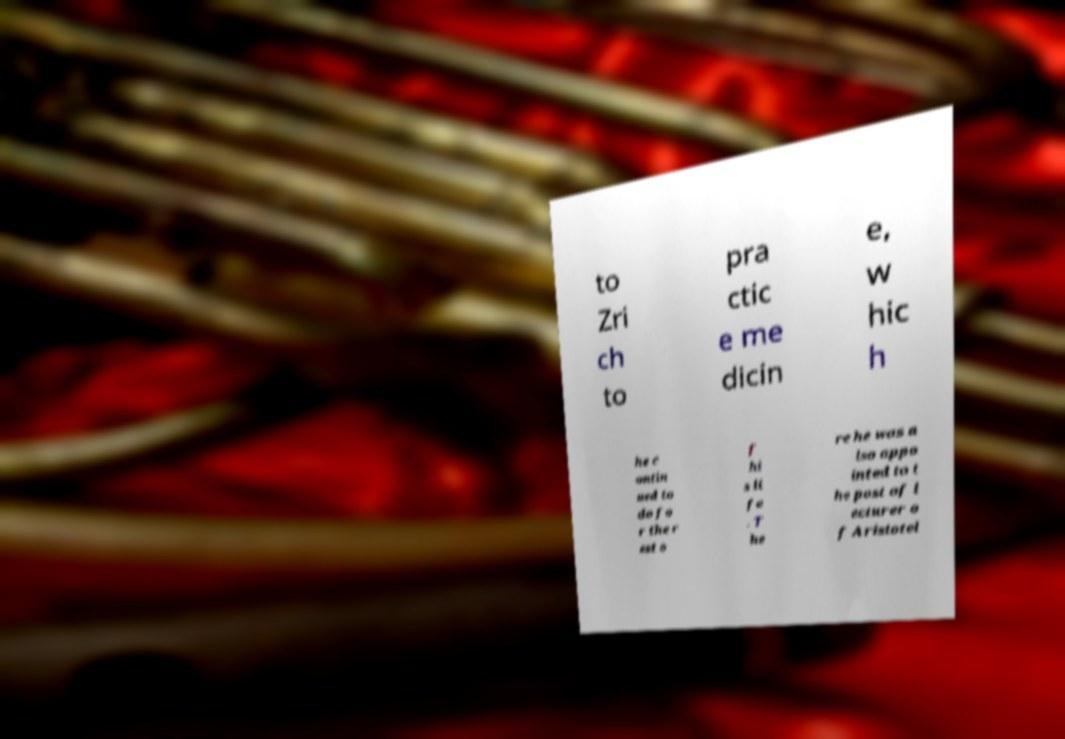For documentation purposes, I need the text within this image transcribed. Could you provide that? to Zri ch to pra ctic e me dicin e, w hic h he c ontin ued to do fo r the r est o f hi s li fe . T he re he was a lso appo inted to t he post of l ecturer o f Aristotel 